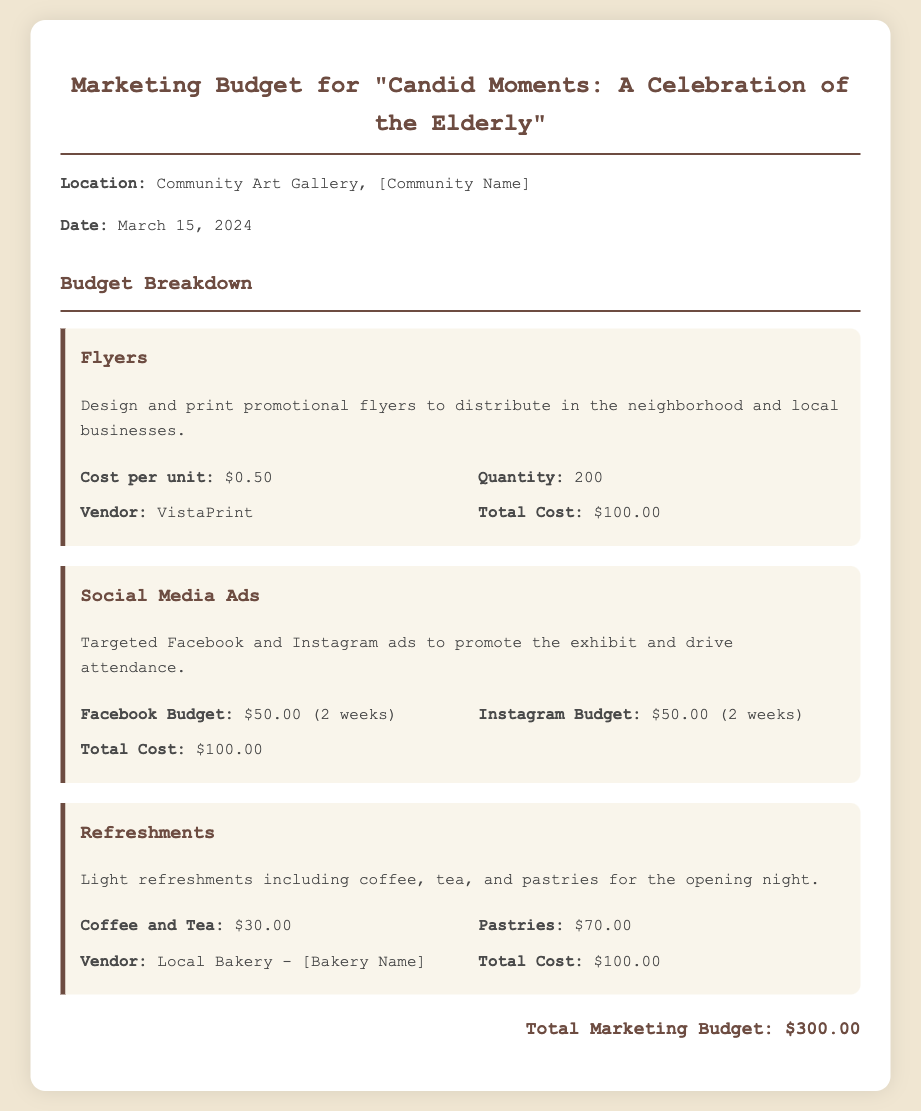What is the title of the exhibit? The title of the exhibit is stated clearly at the top of the document.
Answer: Candid Moments: A Celebration of the Elderly What is the total marketing budget? The total marketing budget is presented at the end of the document, summing up all costs.
Answer: $300.00 How many flyers are going to be printed? The quantity of flyers is specifically mentioned in the flyers section of the document.
Answer: 200 What is the vendor for the flyers? The document specifies the vendor used for printing the flyers in the detailed section of the budget.
Answer: VistaPrint How much is allocated to Facebook ads? The Facebook budget is explicitly mentioned in the social media ads section.
Answer: $50.00 What types of refreshments will be provided? The types of refreshments are outlined in the refreshments section of the document.
Answer: Coffee, tea, and pastries Which local business is mentioned for refreshments? The vendor for refreshments is noted within the refreshments section.
Answer: Local Bakery - [Bakery Name] How much will pastries cost? The cost of pastries is provided in the refreshments budget details.
Answer: $70.00 What is the cost per flyer? The document indicates the cost per unit for the flyers in the budget breakdown.
Answer: $0.50 